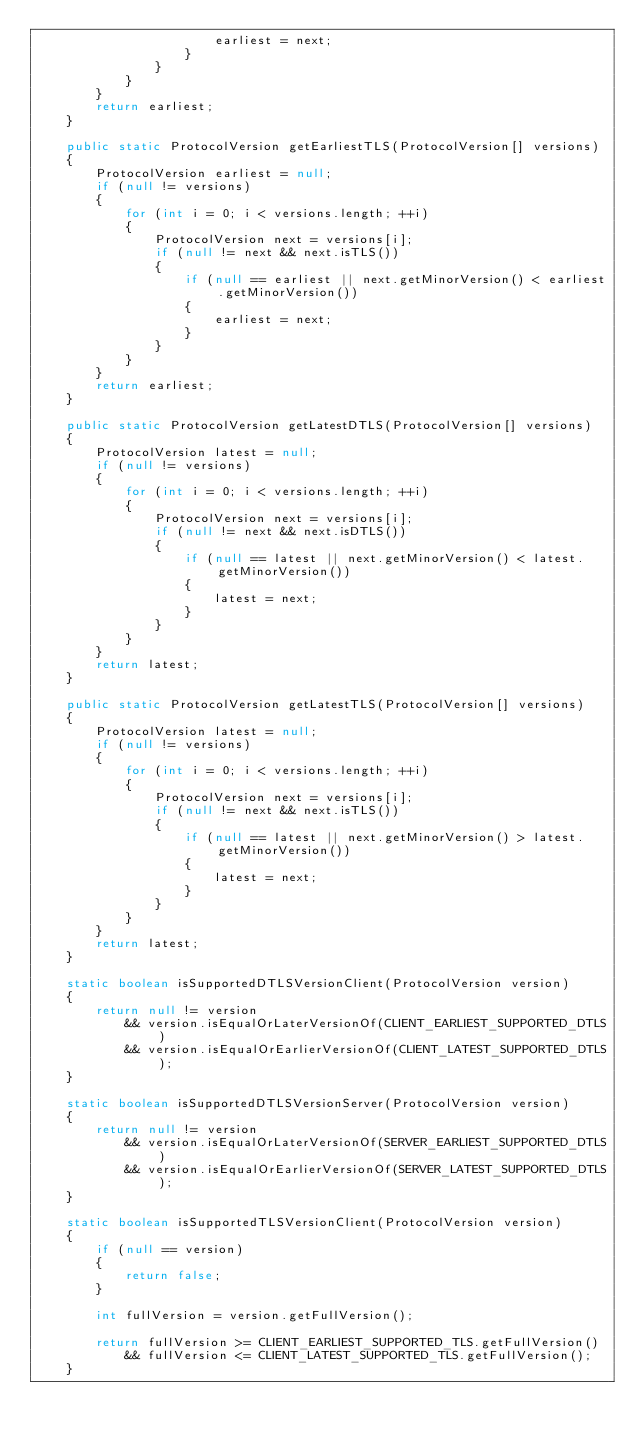Convert code to text. <code><loc_0><loc_0><loc_500><loc_500><_Java_>                        earliest = next;
                    }
                }
            }
        }
        return earliest;
    }

    public static ProtocolVersion getEarliestTLS(ProtocolVersion[] versions)
    {
        ProtocolVersion earliest = null;
        if (null != versions)
        {
            for (int i = 0; i < versions.length; ++i)
            {
                ProtocolVersion next = versions[i];
                if (null != next && next.isTLS())
                {
                    if (null == earliest || next.getMinorVersion() < earliest.getMinorVersion())
                    {
                        earliest = next;
                    }
                }
            }
        }
        return earliest;
    }

    public static ProtocolVersion getLatestDTLS(ProtocolVersion[] versions)
    {
        ProtocolVersion latest = null;
        if (null != versions)
        {
            for (int i = 0; i < versions.length; ++i)
            {
                ProtocolVersion next = versions[i];
                if (null != next && next.isDTLS())
                {
                    if (null == latest || next.getMinorVersion() < latest.getMinorVersion())
                    {
                        latest = next;
                    }
                }
            }
        }
        return latest;
    }

    public static ProtocolVersion getLatestTLS(ProtocolVersion[] versions)
    {
        ProtocolVersion latest = null;
        if (null != versions)
        {
            for (int i = 0; i < versions.length; ++i)
            {
                ProtocolVersion next = versions[i];
                if (null != next && next.isTLS())
                {
                    if (null == latest || next.getMinorVersion() > latest.getMinorVersion())
                    {
                        latest = next;
                    }
                }
            }
        }
        return latest;
    }

    static boolean isSupportedDTLSVersionClient(ProtocolVersion version)
    {
        return null != version
            && version.isEqualOrLaterVersionOf(CLIENT_EARLIEST_SUPPORTED_DTLS)
            && version.isEqualOrEarlierVersionOf(CLIENT_LATEST_SUPPORTED_DTLS);
    }

    static boolean isSupportedDTLSVersionServer(ProtocolVersion version)
    {
        return null != version
            && version.isEqualOrLaterVersionOf(SERVER_EARLIEST_SUPPORTED_DTLS)
            && version.isEqualOrEarlierVersionOf(SERVER_LATEST_SUPPORTED_DTLS);
    }

    static boolean isSupportedTLSVersionClient(ProtocolVersion version)
    {
        if (null == version)
        {
            return false;
        }

        int fullVersion = version.getFullVersion();

        return fullVersion >= CLIENT_EARLIEST_SUPPORTED_TLS.getFullVersion()
            && fullVersion <= CLIENT_LATEST_SUPPORTED_TLS.getFullVersion();
    }
</code> 